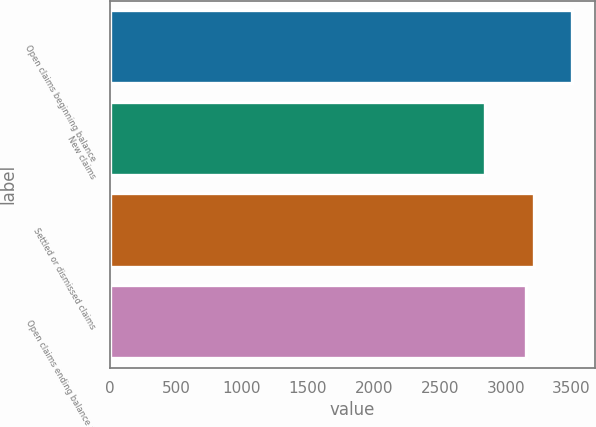Convert chart. <chart><loc_0><loc_0><loc_500><loc_500><bar_chart><fcel>Open claims beginning balance<fcel>New claims<fcel>Settled or dismissed claims<fcel>Open claims ending balance at<nl><fcel>3500<fcel>2843<fcel>3216.7<fcel>3151<nl></chart> 